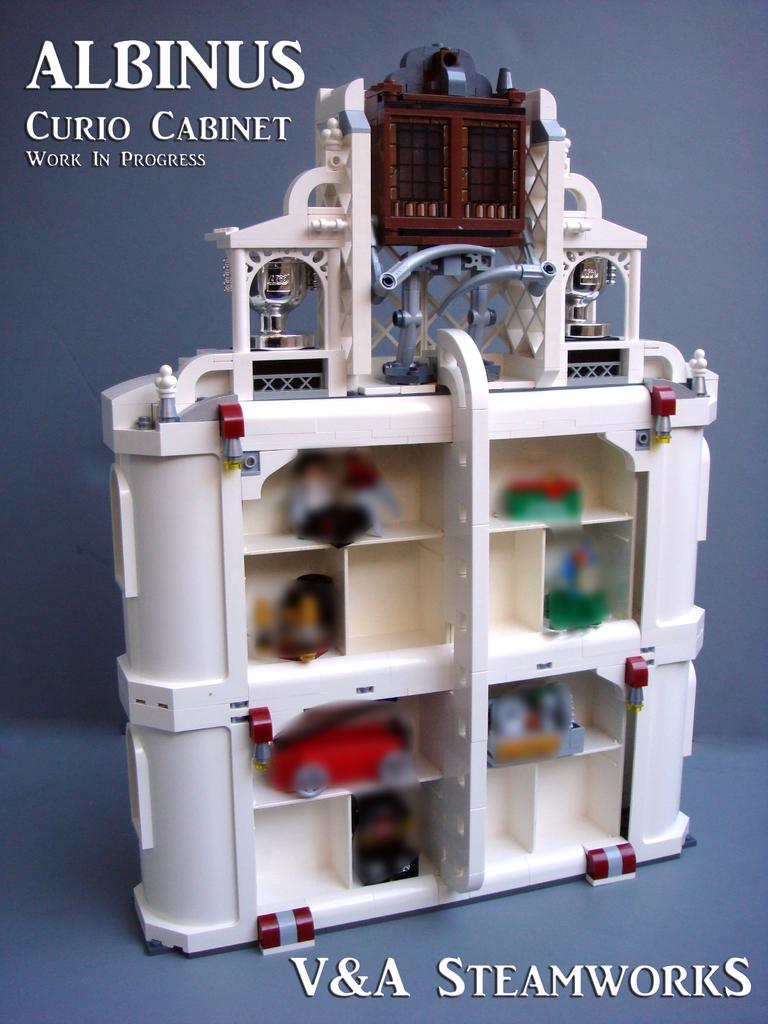<image>
Present a compact description of the photo's key features. A lego version of an Albinus curio cabinet is a work in progress. 